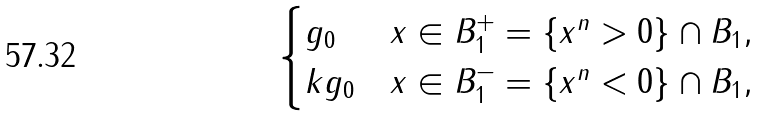Convert formula to latex. <formula><loc_0><loc_0><loc_500><loc_500>\begin{cases} g _ { 0 } & x \in { B } _ { 1 } ^ { + } = \{ x ^ { n } > 0 \} \cap { B } _ { 1 } , \\ k g _ { 0 } & x \in { B } _ { 1 } ^ { - } = \{ x ^ { n } < 0 \} \cap { B } _ { 1 } , \end{cases}</formula> 